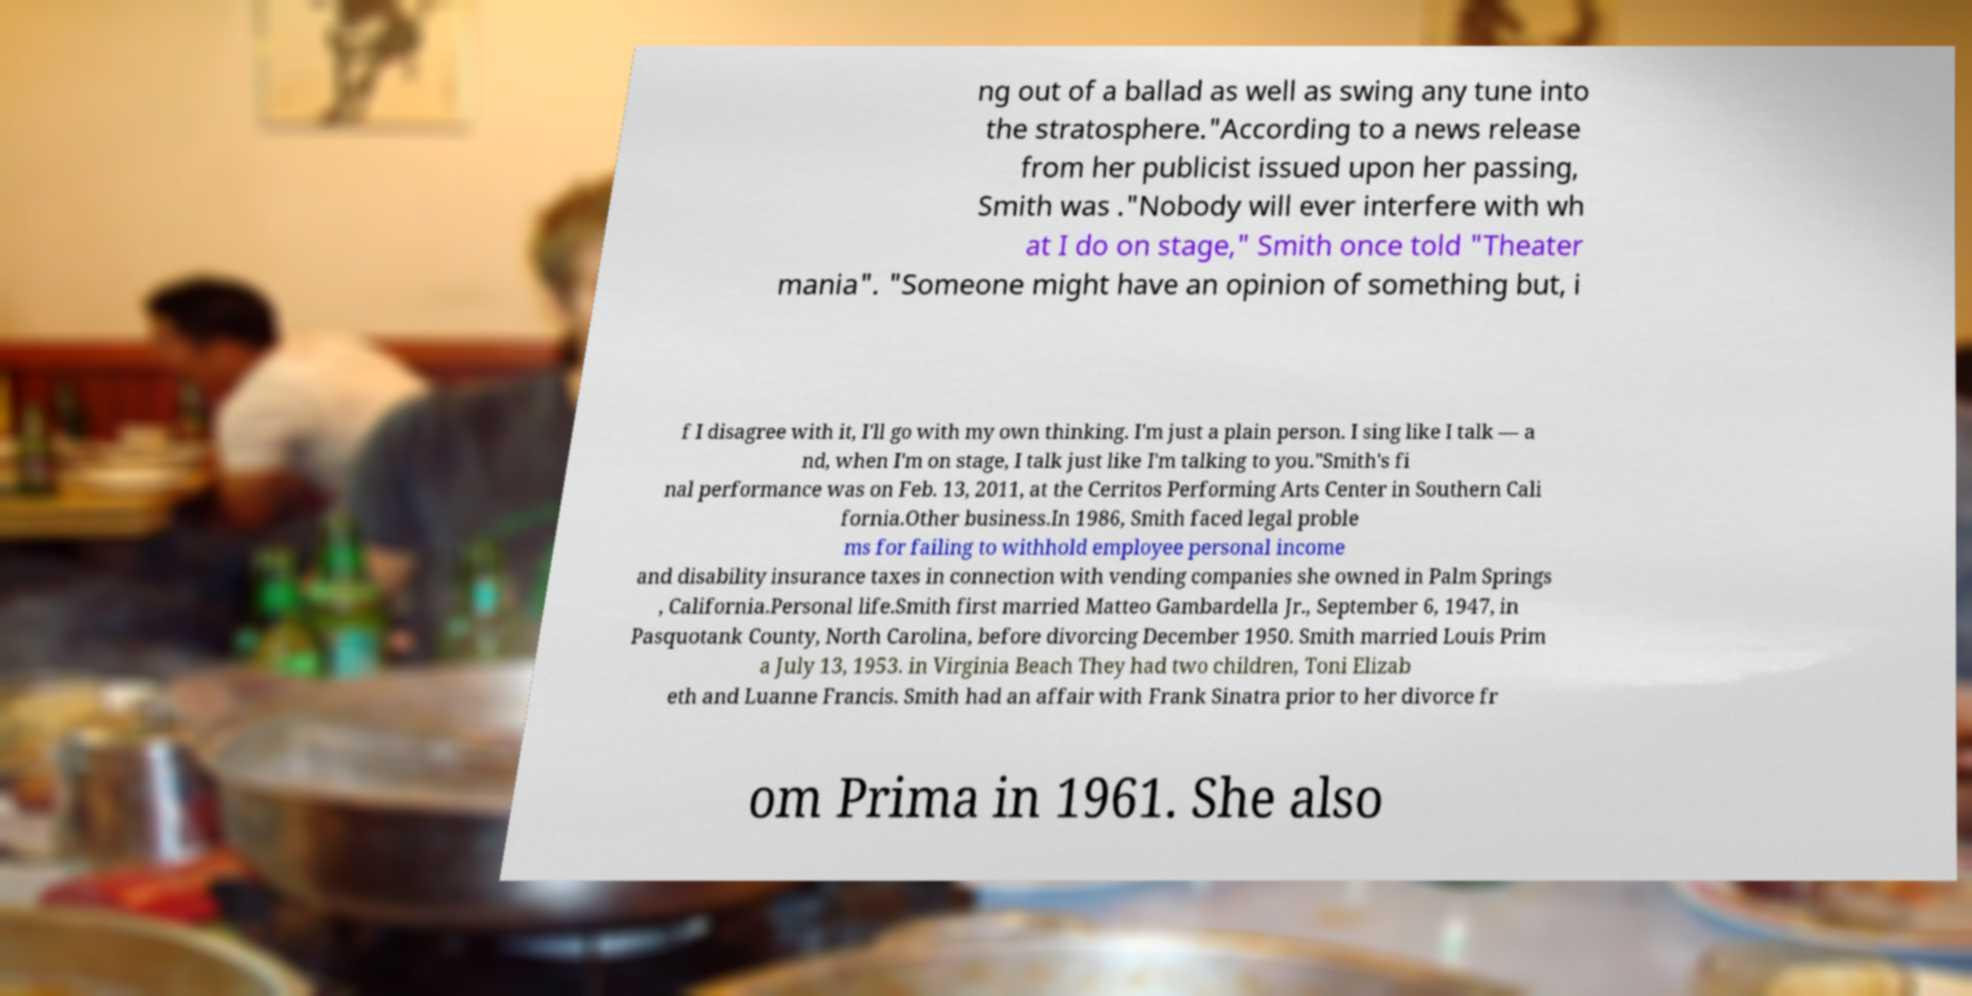I need the written content from this picture converted into text. Can you do that? ng out of a ballad as well as swing any tune into the stratosphere."According to a news release from her publicist issued upon her passing, Smith was ."Nobody will ever interfere with wh at I do on stage," Smith once told "Theater mania". "Someone might have an opinion of something but, i f I disagree with it, I'll go with my own thinking. I'm just a plain person. I sing like I talk — a nd, when I'm on stage, I talk just like I'm talking to you."Smith's fi nal performance was on Feb. 13, 2011, at the Cerritos Performing Arts Center in Southern Cali fornia.Other business.In 1986, Smith faced legal proble ms for failing to withhold employee personal income and disability insurance taxes in connection with vending companies she owned in Palm Springs , California.Personal life.Smith first married Matteo Gambardella Jr., September 6, 1947, in Pasquotank County, North Carolina, before divorcing December 1950. Smith married Louis Prim a July 13, 1953. in Virginia Beach They had two children, Toni Elizab eth and Luanne Francis. Smith had an affair with Frank Sinatra prior to her divorce fr om Prima in 1961. She also 